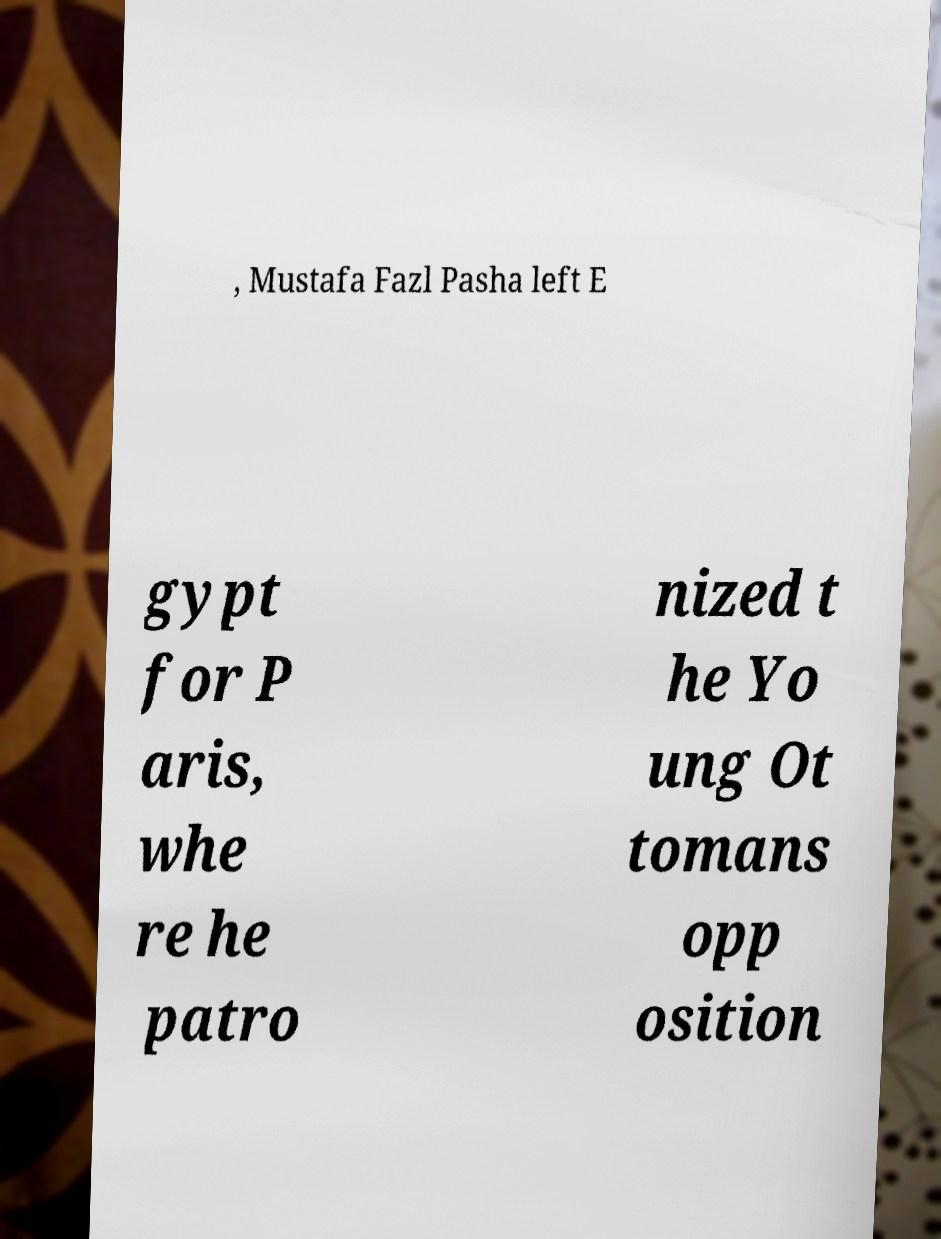There's text embedded in this image that I need extracted. Can you transcribe it verbatim? , Mustafa Fazl Pasha left E gypt for P aris, whe re he patro nized t he Yo ung Ot tomans opp osition 